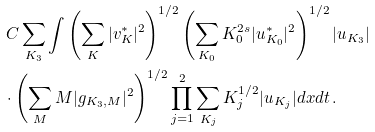Convert formula to latex. <formula><loc_0><loc_0><loc_500><loc_500>& \, C \sum _ { K _ { 3 } } \int \left ( \sum _ { K } | v ^ { * } _ { K } | ^ { 2 } \right ) ^ { 1 / 2 } \left ( \sum _ { K _ { 0 } } K _ { 0 } ^ { 2 s } | u _ { K _ { 0 } } ^ { * } | ^ { 2 } \right ) ^ { 1 / 2 } | u _ { K _ { 3 } } | \\ & \cdot \left ( \sum _ { M } M | g _ { K _ { 3 } , M } | ^ { 2 } \right ) ^ { 1 / 2 } \prod _ { j = 1 } ^ { 2 } \sum _ { K _ { j } } K _ { j } ^ { 1 / 2 } | u _ { K _ { j } } | d x d t \, .</formula> 